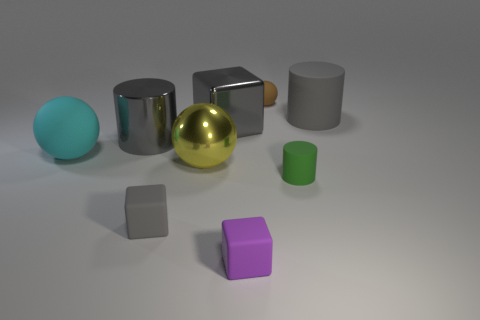What is the lighting condition in the scene? The scene is lit by what appears to be a soft overhead light source, creating a gentle shadow under each object. This indicates a uniformly diffused light, possibly simulating an indoor environment. 